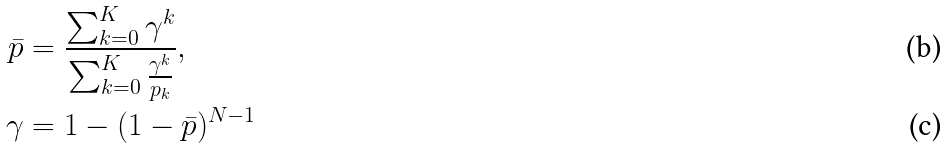Convert formula to latex. <formula><loc_0><loc_0><loc_500><loc_500>\bar { p } & = \frac { \sum _ { k = 0 } ^ { K } \gamma ^ { k } } { \sum _ { k = 0 } ^ { K } \frac { \gamma ^ { k } } { p _ { k } } } , \\ \gamma & = 1 - ( 1 - \bar { p } ) ^ { N - 1 }</formula> 